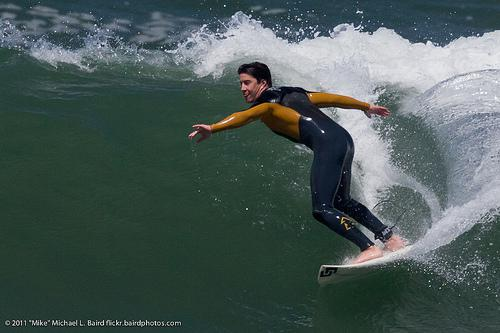Question: how many people are there?
Choices:
A. 12.
B. 1.
C. 10.
D. 7.
Answer with the letter. Answer: B Question: what is the person doing?
Choices:
A. Misspelling words.
B. Writing sentences with incorrect grammar.
C. Surfing.
D. Sleeping.
Answer with the letter. Answer: C Question: who is on the surfboard?
Choices:
A. A female surfer.
B. A child surfer.
C. A dog.
D. A man.
Answer with the letter. Answer: D Question: where is the man?
Choices:
A. In bed.
B. At work.
C. On a wave.
D. In his truck.
Answer with the letter. Answer: C 